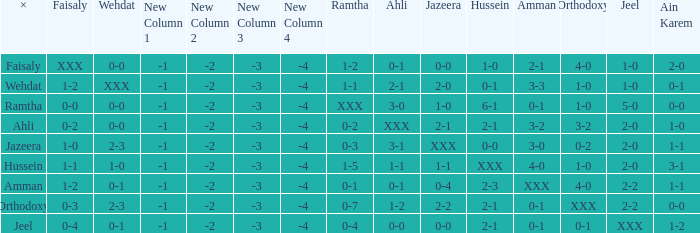What is ramtha when jeel is 1-0 and hussein is 1-0? 1-2. 